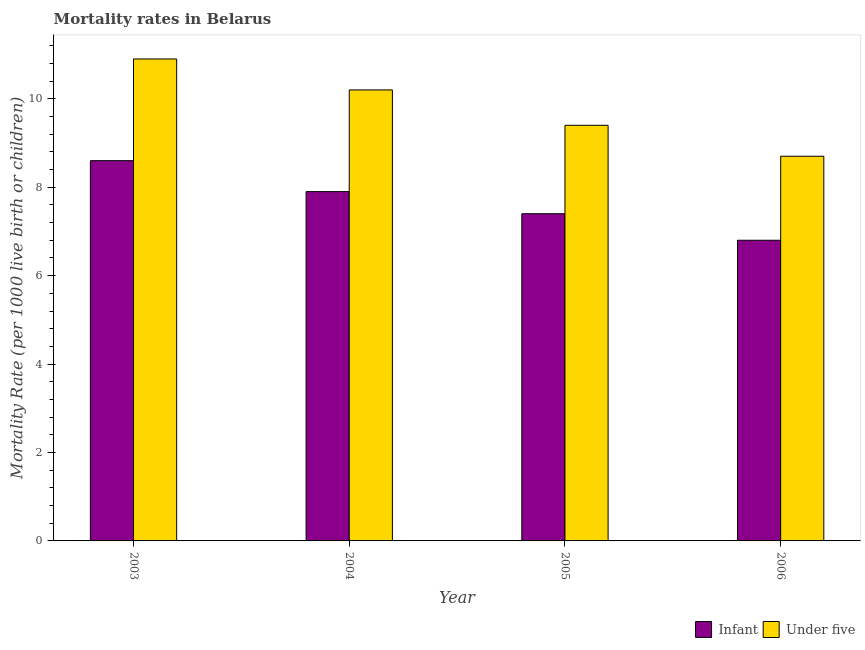How many different coloured bars are there?
Ensure brevity in your answer.  2. Are the number of bars on each tick of the X-axis equal?
Provide a short and direct response. Yes. How many bars are there on the 2nd tick from the right?
Provide a short and direct response. 2. What is the label of the 2nd group of bars from the left?
Provide a succinct answer. 2004. Across all years, what is the maximum infant mortality rate?
Give a very brief answer. 8.6. What is the total infant mortality rate in the graph?
Your answer should be compact. 30.7. What is the difference between the under-5 mortality rate in 2003 and that in 2006?
Your answer should be very brief. 2.2. What is the difference between the infant mortality rate in 2003 and the under-5 mortality rate in 2005?
Give a very brief answer. 1.2. What is the average infant mortality rate per year?
Offer a terse response. 7.67. What is the ratio of the infant mortality rate in 2005 to that in 2006?
Make the answer very short. 1.09. Is the under-5 mortality rate in 2003 less than that in 2004?
Offer a very short reply. No. Is the difference between the infant mortality rate in 2003 and 2004 greater than the difference between the under-5 mortality rate in 2003 and 2004?
Keep it short and to the point. No. What is the difference between the highest and the second highest under-5 mortality rate?
Give a very brief answer. 0.7. What is the difference between the highest and the lowest under-5 mortality rate?
Offer a terse response. 2.2. In how many years, is the infant mortality rate greater than the average infant mortality rate taken over all years?
Keep it short and to the point. 2. What does the 1st bar from the left in 2004 represents?
Provide a succinct answer. Infant. What does the 1st bar from the right in 2003 represents?
Your answer should be very brief. Under five. How many bars are there?
Keep it short and to the point. 8. Are all the bars in the graph horizontal?
Your answer should be compact. No. How many years are there in the graph?
Your answer should be compact. 4. Does the graph contain grids?
Make the answer very short. No. Where does the legend appear in the graph?
Your answer should be compact. Bottom right. How many legend labels are there?
Offer a terse response. 2. What is the title of the graph?
Provide a short and direct response. Mortality rates in Belarus. What is the label or title of the X-axis?
Your response must be concise. Year. What is the label or title of the Y-axis?
Your answer should be very brief. Mortality Rate (per 1000 live birth or children). What is the Mortality Rate (per 1000 live birth or children) in Under five in 2003?
Provide a succinct answer. 10.9. What is the Mortality Rate (per 1000 live birth or children) of Infant in 2004?
Give a very brief answer. 7.9. What is the Mortality Rate (per 1000 live birth or children) in Under five in 2004?
Provide a succinct answer. 10.2. What is the Mortality Rate (per 1000 live birth or children) of Infant in 2005?
Provide a short and direct response. 7.4. Across all years, what is the maximum Mortality Rate (per 1000 live birth or children) in Infant?
Provide a short and direct response. 8.6. Across all years, what is the minimum Mortality Rate (per 1000 live birth or children) in Infant?
Your response must be concise. 6.8. What is the total Mortality Rate (per 1000 live birth or children) in Infant in the graph?
Your answer should be compact. 30.7. What is the total Mortality Rate (per 1000 live birth or children) in Under five in the graph?
Give a very brief answer. 39.2. What is the difference between the Mortality Rate (per 1000 live birth or children) of Infant in 2003 and that in 2005?
Give a very brief answer. 1.2. What is the difference between the Mortality Rate (per 1000 live birth or children) of Infant in 2003 and that in 2006?
Your answer should be compact. 1.8. What is the difference between the Mortality Rate (per 1000 live birth or children) in Under five in 2003 and that in 2006?
Make the answer very short. 2.2. What is the difference between the Mortality Rate (per 1000 live birth or children) in Infant in 2004 and that in 2005?
Your answer should be very brief. 0.5. What is the difference between the Mortality Rate (per 1000 live birth or children) in Under five in 2004 and that in 2005?
Offer a very short reply. 0.8. What is the difference between the Mortality Rate (per 1000 live birth or children) of Under five in 2004 and that in 2006?
Offer a very short reply. 1.5. What is the difference between the Mortality Rate (per 1000 live birth or children) in Infant in 2003 and the Mortality Rate (per 1000 live birth or children) in Under five in 2004?
Make the answer very short. -1.6. What is the difference between the Mortality Rate (per 1000 live birth or children) of Infant in 2003 and the Mortality Rate (per 1000 live birth or children) of Under five in 2005?
Give a very brief answer. -0.8. What is the difference between the Mortality Rate (per 1000 live birth or children) of Infant in 2003 and the Mortality Rate (per 1000 live birth or children) of Under five in 2006?
Ensure brevity in your answer.  -0.1. What is the difference between the Mortality Rate (per 1000 live birth or children) in Infant in 2005 and the Mortality Rate (per 1000 live birth or children) in Under five in 2006?
Make the answer very short. -1.3. What is the average Mortality Rate (per 1000 live birth or children) in Infant per year?
Keep it short and to the point. 7.67. What is the ratio of the Mortality Rate (per 1000 live birth or children) of Infant in 2003 to that in 2004?
Provide a succinct answer. 1.09. What is the ratio of the Mortality Rate (per 1000 live birth or children) in Under five in 2003 to that in 2004?
Your response must be concise. 1.07. What is the ratio of the Mortality Rate (per 1000 live birth or children) in Infant in 2003 to that in 2005?
Make the answer very short. 1.16. What is the ratio of the Mortality Rate (per 1000 live birth or children) of Under five in 2003 to that in 2005?
Your response must be concise. 1.16. What is the ratio of the Mortality Rate (per 1000 live birth or children) of Infant in 2003 to that in 2006?
Make the answer very short. 1.26. What is the ratio of the Mortality Rate (per 1000 live birth or children) of Under five in 2003 to that in 2006?
Offer a very short reply. 1.25. What is the ratio of the Mortality Rate (per 1000 live birth or children) in Infant in 2004 to that in 2005?
Provide a short and direct response. 1.07. What is the ratio of the Mortality Rate (per 1000 live birth or children) in Under five in 2004 to that in 2005?
Offer a very short reply. 1.09. What is the ratio of the Mortality Rate (per 1000 live birth or children) in Infant in 2004 to that in 2006?
Provide a short and direct response. 1.16. What is the ratio of the Mortality Rate (per 1000 live birth or children) of Under five in 2004 to that in 2006?
Ensure brevity in your answer.  1.17. What is the ratio of the Mortality Rate (per 1000 live birth or children) in Infant in 2005 to that in 2006?
Keep it short and to the point. 1.09. What is the ratio of the Mortality Rate (per 1000 live birth or children) in Under five in 2005 to that in 2006?
Provide a succinct answer. 1.08. What is the difference between the highest and the second highest Mortality Rate (per 1000 live birth or children) of Infant?
Keep it short and to the point. 0.7. What is the difference between the highest and the second highest Mortality Rate (per 1000 live birth or children) in Under five?
Your answer should be compact. 0.7. What is the difference between the highest and the lowest Mortality Rate (per 1000 live birth or children) of Under five?
Offer a terse response. 2.2. 